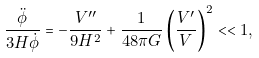Convert formula to latex. <formula><loc_0><loc_0><loc_500><loc_500>\frac { \ddot { \phi } } { 3 H \dot { \phi } } = - \frac { V ^ { \prime \prime } } { 9 H ^ { 2 } } + \frac { 1 } { 4 8 \pi G } \left ( \frac { V ^ { \prime } } { V } \right ) ^ { 2 } < < 1 ,</formula> 